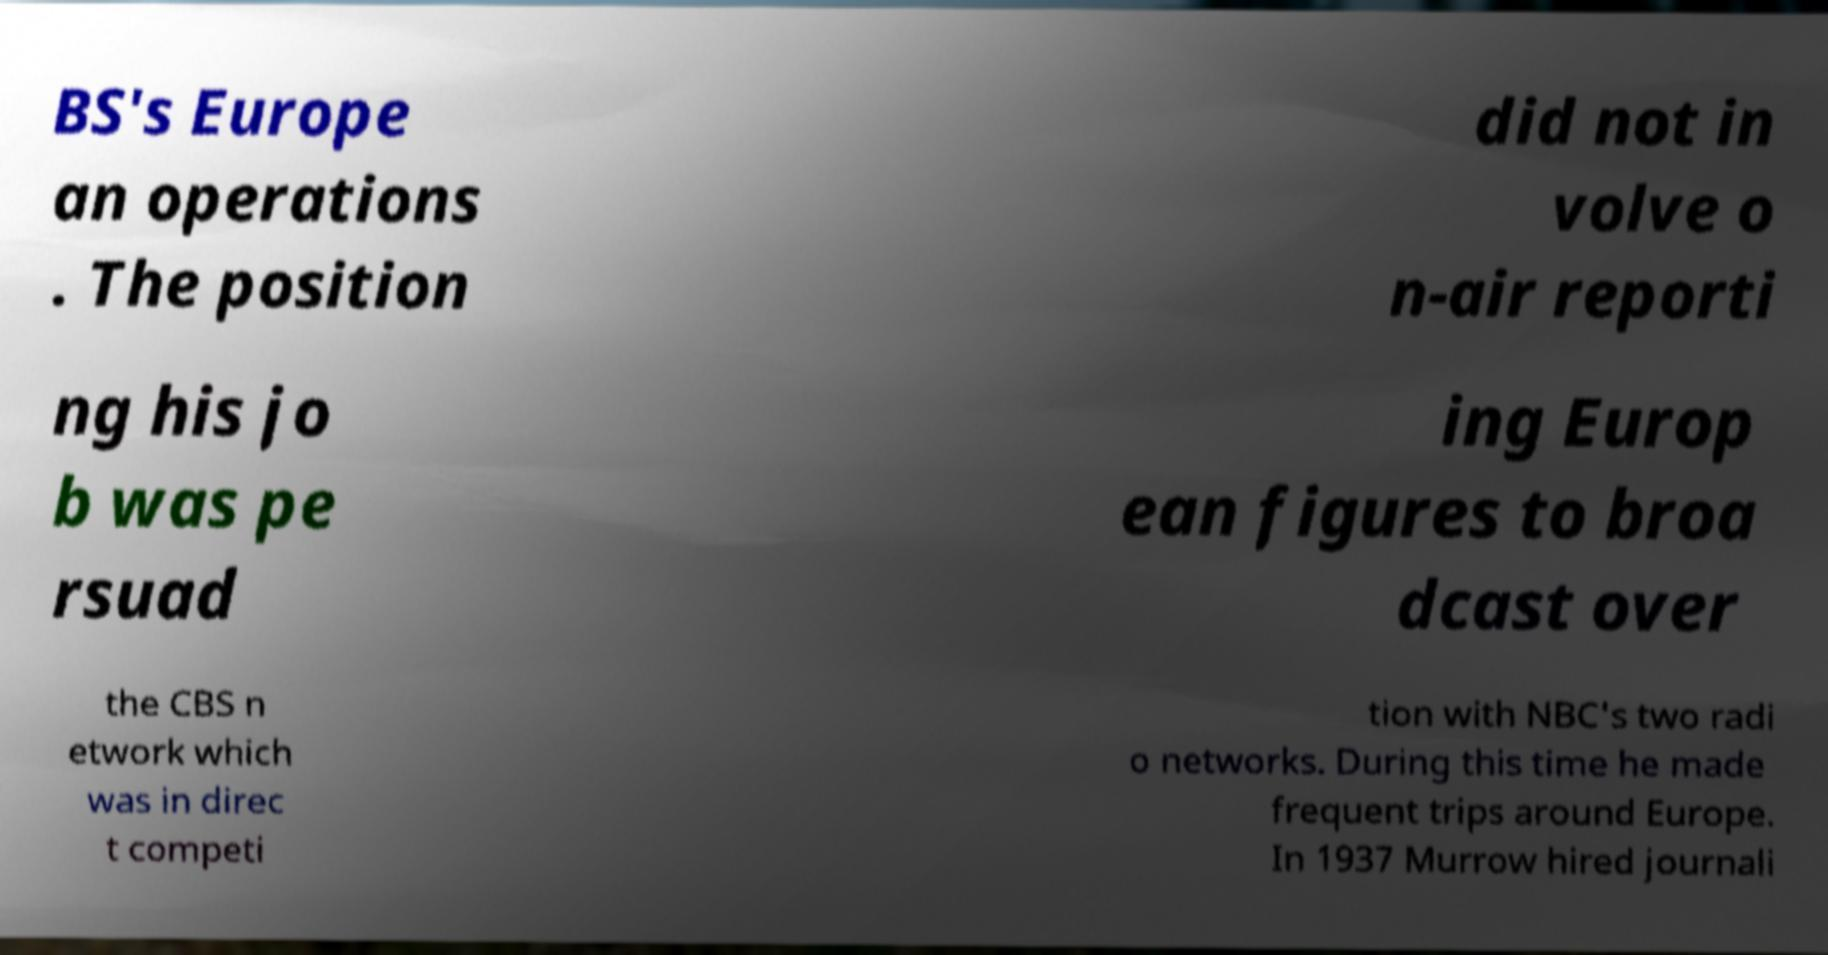Can you accurately transcribe the text from the provided image for me? BS's Europe an operations . The position did not in volve o n-air reporti ng his jo b was pe rsuad ing Europ ean figures to broa dcast over the CBS n etwork which was in direc t competi tion with NBC's two radi o networks. During this time he made frequent trips around Europe. In 1937 Murrow hired journali 